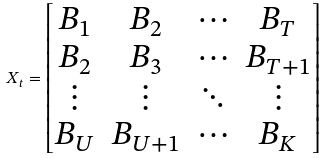<formula> <loc_0><loc_0><loc_500><loc_500>X _ { t } = \begin{bmatrix} B _ { 1 } & B _ { 2 } & \cdots & B _ { T } \\ B _ { 2 } & B _ { 3 } & \cdots & B _ { T + 1 } \\ \vdots & \vdots & \ddots & \vdots \\ B _ { U } & B _ { U + 1 } & \cdots & B _ { K } \\ \end{bmatrix}</formula> 